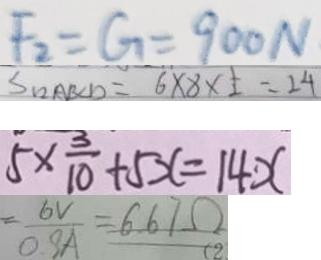Convert formula to latex. <formula><loc_0><loc_0><loc_500><loc_500>F _ { 2 } = G = 9 0 0 N 
 S _ { 1 2 A B C D } = 6 \times 8 \times \frac { 1 } { 2 } = 2 4 
 5 \times \frac { 3 } { 1 0 } + 5 x = 1 4 x 
 = \frac { 6 V } { 0 . 9 A } = 6 . 6 7 \Omega</formula> 